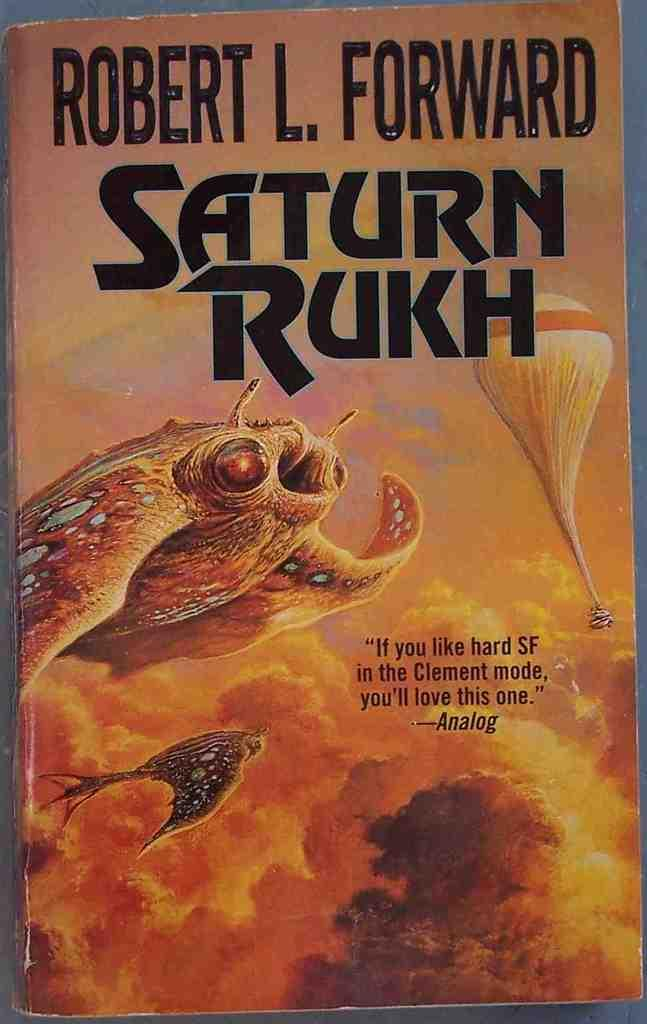<image>
Offer a succinct explanation of the picture presented. Saturn Rukh book has a yellow cover with a weird fish on it 